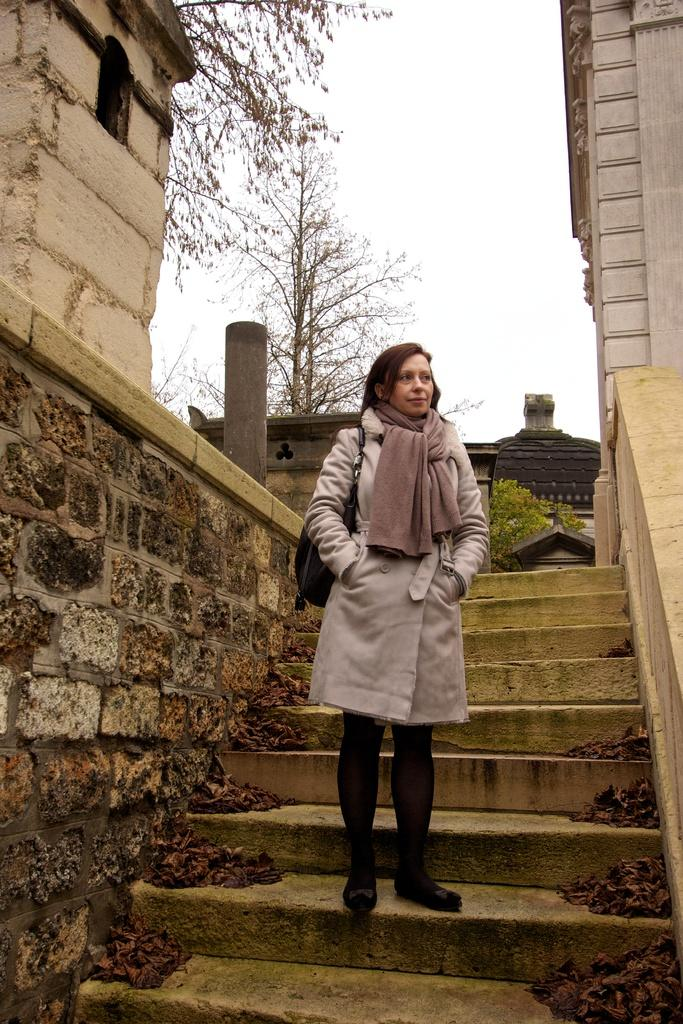What is the main subject of the image? There is a woman standing in the center of the image. What can be seen in the background of the image? There are stairs, trees, and a building in the background of the image. What is on the left side of the image? There is a wall on the left side of the image. What type of whip is being used by the woman in the image? There is no whip present in the image; the woman is simply standing. 